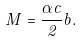Convert formula to latex. <formula><loc_0><loc_0><loc_500><loc_500>M = \frac { \alpha c } { 2 } b .</formula> 